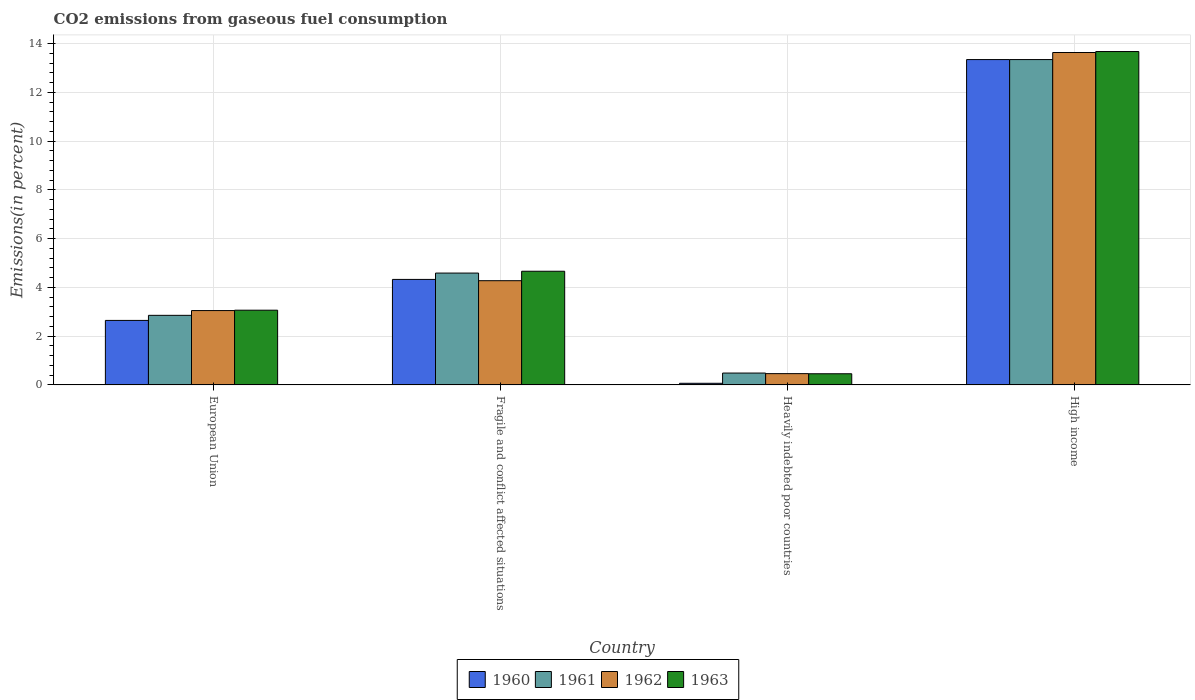How many groups of bars are there?
Provide a succinct answer. 4. How many bars are there on the 4th tick from the left?
Ensure brevity in your answer.  4. How many bars are there on the 1st tick from the right?
Keep it short and to the point. 4. What is the total CO2 emitted in 1962 in High income?
Your response must be concise. 13.63. Across all countries, what is the maximum total CO2 emitted in 1960?
Give a very brief answer. 13.34. Across all countries, what is the minimum total CO2 emitted in 1962?
Offer a very short reply. 0.46. In which country was the total CO2 emitted in 1960 minimum?
Offer a very short reply. Heavily indebted poor countries. What is the total total CO2 emitted in 1960 in the graph?
Provide a succinct answer. 20.38. What is the difference between the total CO2 emitted in 1961 in European Union and that in Heavily indebted poor countries?
Give a very brief answer. 2.37. What is the difference between the total CO2 emitted in 1962 in European Union and the total CO2 emitted in 1960 in Heavily indebted poor countries?
Provide a short and direct response. 2.98. What is the average total CO2 emitted in 1963 per country?
Give a very brief answer. 5.46. What is the difference between the total CO2 emitted of/in 1961 and total CO2 emitted of/in 1962 in Fragile and conflict affected situations?
Provide a short and direct response. 0.31. What is the ratio of the total CO2 emitted in 1963 in Fragile and conflict affected situations to that in Heavily indebted poor countries?
Ensure brevity in your answer.  10.19. Is the total CO2 emitted in 1963 in Fragile and conflict affected situations less than that in High income?
Make the answer very short. Yes. Is the difference between the total CO2 emitted in 1961 in Fragile and conflict affected situations and High income greater than the difference between the total CO2 emitted in 1962 in Fragile and conflict affected situations and High income?
Your response must be concise. Yes. What is the difference between the highest and the second highest total CO2 emitted in 1963?
Make the answer very short. -1.6. What is the difference between the highest and the lowest total CO2 emitted in 1963?
Ensure brevity in your answer.  13.22. Is the sum of the total CO2 emitted in 1963 in European Union and High income greater than the maximum total CO2 emitted in 1960 across all countries?
Provide a succinct answer. Yes. What does the 2nd bar from the left in European Union represents?
Ensure brevity in your answer.  1961. Is it the case that in every country, the sum of the total CO2 emitted in 1962 and total CO2 emitted in 1960 is greater than the total CO2 emitted in 1963?
Your response must be concise. Yes. How many bars are there?
Make the answer very short. 16. Are all the bars in the graph horizontal?
Ensure brevity in your answer.  No. How many countries are there in the graph?
Offer a very short reply. 4. What is the title of the graph?
Ensure brevity in your answer.  CO2 emissions from gaseous fuel consumption. Does "1987" appear as one of the legend labels in the graph?
Your response must be concise. No. What is the label or title of the X-axis?
Your response must be concise. Country. What is the label or title of the Y-axis?
Ensure brevity in your answer.  Emissions(in percent). What is the Emissions(in percent) in 1960 in European Union?
Ensure brevity in your answer.  2.65. What is the Emissions(in percent) of 1961 in European Union?
Give a very brief answer. 2.85. What is the Emissions(in percent) in 1962 in European Union?
Keep it short and to the point. 3.05. What is the Emissions(in percent) in 1963 in European Union?
Your answer should be very brief. 3.06. What is the Emissions(in percent) of 1960 in Fragile and conflict affected situations?
Your response must be concise. 4.33. What is the Emissions(in percent) of 1961 in Fragile and conflict affected situations?
Your answer should be compact. 4.59. What is the Emissions(in percent) in 1962 in Fragile and conflict affected situations?
Offer a very short reply. 4.27. What is the Emissions(in percent) in 1963 in Fragile and conflict affected situations?
Provide a short and direct response. 4.66. What is the Emissions(in percent) of 1960 in Heavily indebted poor countries?
Provide a short and direct response. 0.07. What is the Emissions(in percent) of 1961 in Heavily indebted poor countries?
Offer a terse response. 0.49. What is the Emissions(in percent) of 1962 in Heavily indebted poor countries?
Provide a succinct answer. 0.46. What is the Emissions(in percent) of 1963 in Heavily indebted poor countries?
Your answer should be very brief. 0.46. What is the Emissions(in percent) of 1960 in High income?
Keep it short and to the point. 13.34. What is the Emissions(in percent) in 1961 in High income?
Make the answer very short. 13.35. What is the Emissions(in percent) of 1962 in High income?
Provide a short and direct response. 13.63. What is the Emissions(in percent) in 1963 in High income?
Give a very brief answer. 13.67. Across all countries, what is the maximum Emissions(in percent) of 1960?
Offer a terse response. 13.34. Across all countries, what is the maximum Emissions(in percent) in 1961?
Your answer should be very brief. 13.35. Across all countries, what is the maximum Emissions(in percent) in 1962?
Offer a very short reply. 13.63. Across all countries, what is the maximum Emissions(in percent) of 1963?
Give a very brief answer. 13.67. Across all countries, what is the minimum Emissions(in percent) in 1960?
Offer a terse response. 0.07. Across all countries, what is the minimum Emissions(in percent) in 1961?
Your response must be concise. 0.49. Across all countries, what is the minimum Emissions(in percent) in 1962?
Your answer should be compact. 0.46. Across all countries, what is the minimum Emissions(in percent) in 1963?
Keep it short and to the point. 0.46. What is the total Emissions(in percent) in 1960 in the graph?
Provide a short and direct response. 20.38. What is the total Emissions(in percent) in 1961 in the graph?
Offer a terse response. 21.27. What is the total Emissions(in percent) of 1962 in the graph?
Provide a short and direct response. 21.42. What is the total Emissions(in percent) of 1963 in the graph?
Your response must be concise. 21.86. What is the difference between the Emissions(in percent) of 1960 in European Union and that in Fragile and conflict affected situations?
Make the answer very short. -1.68. What is the difference between the Emissions(in percent) in 1961 in European Union and that in Fragile and conflict affected situations?
Provide a short and direct response. -1.73. What is the difference between the Emissions(in percent) in 1962 in European Union and that in Fragile and conflict affected situations?
Your answer should be very brief. -1.23. What is the difference between the Emissions(in percent) of 1963 in European Union and that in Fragile and conflict affected situations?
Your answer should be very brief. -1.6. What is the difference between the Emissions(in percent) of 1960 in European Union and that in Heavily indebted poor countries?
Make the answer very short. 2.58. What is the difference between the Emissions(in percent) of 1961 in European Union and that in Heavily indebted poor countries?
Provide a short and direct response. 2.37. What is the difference between the Emissions(in percent) of 1962 in European Union and that in Heavily indebted poor countries?
Keep it short and to the point. 2.59. What is the difference between the Emissions(in percent) in 1963 in European Union and that in Heavily indebted poor countries?
Ensure brevity in your answer.  2.61. What is the difference between the Emissions(in percent) in 1960 in European Union and that in High income?
Provide a succinct answer. -10.7. What is the difference between the Emissions(in percent) of 1961 in European Union and that in High income?
Provide a short and direct response. -10.49. What is the difference between the Emissions(in percent) in 1962 in European Union and that in High income?
Offer a terse response. -10.59. What is the difference between the Emissions(in percent) in 1963 in European Union and that in High income?
Offer a terse response. -10.61. What is the difference between the Emissions(in percent) of 1960 in Fragile and conflict affected situations and that in Heavily indebted poor countries?
Ensure brevity in your answer.  4.26. What is the difference between the Emissions(in percent) of 1961 in Fragile and conflict affected situations and that in Heavily indebted poor countries?
Offer a terse response. 4.1. What is the difference between the Emissions(in percent) of 1962 in Fragile and conflict affected situations and that in Heavily indebted poor countries?
Provide a short and direct response. 3.81. What is the difference between the Emissions(in percent) in 1963 in Fragile and conflict affected situations and that in Heavily indebted poor countries?
Your answer should be compact. 4.2. What is the difference between the Emissions(in percent) of 1960 in Fragile and conflict affected situations and that in High income?
Offer a very short reply. -9.02. What is the difference between the Emissions(in percent) of 1961 in Fragile and conflict affected situations and that in High income?
Ensure brevity in your answer.  -8.76. What is the difference between the Emissions(in percent) in 1962 in Fragile and conflict affected situations and that in High income?
Offer a terse response. -9.36. What is the difference between the Emissions(in percent) in 1963 in Fragile and conflict affected situations and that in High income?
Make the answer very short. -9.01. What is the difference between the Emissions(in percent) in 1960 in Heavily indebted poor countries and that in High income?
Provide a short and direct response. -13.28. What is the difference between the Emissions(in percent) in 1961 in Heavily indebted poor countries and that in High income?
Provide a short and direct response. -12.86. What is the difference between the Emissions(in percent) of 1962 in Heavily indebted poor countries and that in High income?
Keep it short and to the point. -13.17. What is the difference between the Emissions(in percent) in 1963 in Heavily indebted poor countries and that in High income?
Your answer should be very brief. -13.22. What is the difference between the Emissions(in percent) in 1960 in European Union and the Emissions(in percent) in 1961 in Fragile and conflict affected situations?
Your answer should be very brief. -1.94. What is the difference between the Emissions(in percent) in 1960 in European Union and the Emissions(in percent) in 1962 in Fragile and conflict affected situations?
Your answer should be very brief. -1.63. What is the difference between the Emissions(in percent) of 1960 in European Union and the Emissions(in percent) of 1963 in Fragile and conflict affected situations?
Provide a short and direct response. -2.02. What is the difference between the Emissions(in percent) of 1961 in European Union and the Emissions(in percent) of 1962 in Fragile and conflict affected situations?
Your answer should be compact. -1.42. What is the difference between the Emissions(in percent) of 1961 in European Union and the Emissions(in percent) of 1963 in Fragile and conflict affected situations?
Give a very brief answer. -1.81. What is the difference between the Emissions(in percent) in 1962 in European Union and the Emissions(in percent) in 1963 in Fragile and conflict affected situations?
Offer a terse response. -1.61. What is the difference between the Emissions(in percent) of 1960 in European Union and the Emissions(in percent) of 1961 in Heavily indebted poor countries?
Your answer should be compact. 2.16. What is the difference between the Emissions(in percent) in 1960 in European Union and the Emissions(in percent) in 1962 in Heavily indebted poor countries?
Offer a very short reply. 2.18. What is the difference between the Emissions(in percent) of 1960 in European Union and the Emissions(in percent) of 1963 in Heavily indebted poor countries?
Provide a short and direct response. 2.19. What is the difference between the Emissions(in percent) of 1961 in European Union and the Emissions(in percent) of 1962 in Heavily indebted poor countries?
Keep it short and to the point. 2.39. What is the difference between the Emissions(in percent) of 1961 in European Union and the Emissions(in percent) of 1963 in Heavily indebted poor countries?
Your answer should be compact. 2.4. What is the difference between the Emissions(in percent) of 1962 in European Union and the Emissions(in percent) of 1963 in Heavily indebted poor countries?
Keep it short and to the point. 2.59. What is the difference between the Emissions(in percent) in 1960 in European Union and the Emissions(in percent) in 1961 in High income?
Your response must be concise. -10.7. What is the difference between the Emissions(in percent) of 1960 in European Union and the Emissions(in percent) of 1962 in High income?
Keep it short and to the point. -10.99. What is the difference between the Emissions(in percent) in 1960 in European Union and the Emissions(in percent) in 1963 in High income?
Make the answer very short. -11.03. What is the difference between the Emissions(in percent) in 1961 in European Union and the Emissions(in percent) in 1962 in High income?
Your answer should be compact. -10.78. What is the difference between the Emissions(in percent) of 1961 in European Union and the Emissions(in percent) of 1963 in High income?
Provide a short and direct response. -10.82. What is the difference between the Emissions(in percent) of 1962 in European Union and the Emissions(in percent) of 1963 in High income?
Give a very brief answer. -10.62. What is the difference between the Emissions(in percent) in 1960 in Fragile and conflict affected situations and the Emissions(in percent) in 1961 in Heavily indebted poor countries?
Offer a terse response. 3.84. What is the difference between the Emissions(in percent) of 1960 in Fragile and conflict affected situations and the Emissions(in percent) of 1962 in Heavily indebted poor countries?
Ensure brevity in your answer.  3.86. What is the difference between the Emissions(in percent) in 1960 in Fragile and conflict affected situations and the Emissions(in percent) in 1963 in Heavily indebted poor countries?
Your response must be concise. 3.87. What is the difference between the Emissions(in percent) in 1961 in Fragile and conflict affected situations and the Emissions(in percent) in 1962 in Heavily indebted poor countries?
Offer a terse response. 4.12. What is the difference between the Emissions(in percent) of 1961 in Fragile and conflict affected situations and the Emissions(in percent) of 1963 in Heavily indebted poor countries?
Offer a very short reply. 4.13. What is the difference between the Emissions(in percent) of 1962 in Fragile and conflict affected situations and the Emissions(in percent) of 1963 in Heavily indebted poor countries?
Offer a terse response. 3.82. What is the difference between the Emissions(in percent) of 1960 in Fragile and conflict affected situations and the Emissions(in percent) of 1961 in High income?
Your answer should be compact. -9.02. What is the difference between the Emissions(in percent) in 1960 in Fragile and conflict affected situations and the Emissions(in percent) in 1962 in High income?
Provide a short and direct response. -9.31. What is the difference between the Emissions(in percent) in 1960 in Fragile and conflict affected situations and the Emissions(in percent) in 1963 in High income?
Make the answer very short. -9.35. What is the difference between the Emissions(in percent) in 1961 in Fragile and conflict affected situations and the Emissions(in percent) in 1962 in High income?
Your answer should be very brief. -9.05. What is the difference between the Emissions(in percent) of 1961 in Fragile and conflict affected situations and the Emissions(in percent) of 1963 in High income?
Keep it short and to the point. -9.09. What is the difference between the Emissions(in percent) of 1962 in Fragile and conflict affected situations and the Emissions(in percent) of 1963 in High income?
Provide a succinct answer. -9.4. What is the difference between the Emissions(in percent) of 1960 in Heavily indebted poor countries and the Emissions(in percent) of 1961 in High income?
Ensure brevity in your answer.  -13.28. What is the difference between the Emissions(in percent) in 1960 in Heavily indebted poor countries and the Emissions(in percent) in 1962 in High income?
Provide a short and direct response. -13.57. What is the difference between the Emissions(in percent) of 1960 in Heavily indebted poor countries and the Emissions(in percent) of 1963 in High income?
Offer a very short reply. -13.61. What is the difference between the Emissions(in percent) of 1961 in Heavily indebted poor countries and the Emissions(in percent) of 1962 in High income?
Your answer should be compact. -13.15. What is the difference between the Emissions(in percent) in 1961 in Heavily indebted poor countries and the Emissions(in percent) in 1963 in High income?
Give a very brief answer. -13.19. What is the difference between the Emissions(in percent) of 1962 in Heavily indebted poor countries and the Emissions(in percent) of 1963 in High income?
Provide a short and direct response. -13.21. What is the average Emissions(in percent) of 1960 per country?
Make the answer very short. 5.1. What is the average Emissions(in percent) in 1961 per country?
Ensure brevity in your answer.  5.32. What is the average Emissions(in percent) of 1962 per country?
Make the answer very short. 5.36. What is the average Emissions(in percent) in 1963 per country?
Offer a very short reply. 5.46. What is the difference between the Emissions(in percent) in 1960 and Emissions(in percent) in 1961 in European Union?
Your answer should be very brief. -0.21. What is the difference between the Emissions(in percent) in 1960 and Emissions(in percent) in 1962 in European Union?
Give a very brief answer. -0.4. What is the difference between the Emissions(in percent) in 1960 and Emissions(in percent) in 1963 in European Union?
Your answer should be very brief. -0.42. What is the difference between the Emissions(in percent) in 1961 and Emissions(in percent) in 1962 in European Union?
Make the answer very short. -0.2. What is the difference between the Emissions(in percent) in 1961 and Emissions(in percent) in 1963 in European Union?
Your response must be concise. -0.21. What is the difference between the Emissions(in percent) of 1962 and Emissions(in percent) of 1963 in European Union?
Keep it short and to the point. -0.01. What is the difference between the Emissions(in percent) of 1960 and Emissions(in percent) of 1961 in Fragile and conflict affected situations?
Keep it short and to the point. -0.26. What is the difference between the Emissions(in percent) of 1960 and Emissions(in percent) of 1962 in Fragile and conflict affected situations?
Make the answer very short. 0.05. What is the difference between the Emissions(in percent) of 1960 and Emissions(in percent) of 1963 in Fragile and conflict affected situations?
Provide a succinct answer. -0.34. What is the difference between the Emissions(in percent) of 1961 and Emissions(in percent) of 1962 in Fragile and conflict affected situations?
Ensure brevity in your answer.  0.31. What is the difference between the Emissions(in percent) of 1961 and Emissions(in percent) of 1963 in Fragile and conflict affected situations?
Offer a terse response. -0.07. What is the difference between the Emissions(in percent) in 1962 and Emissions(in percent) in 1963 in Fragile and conflict affected situations?
Ensure brevity in your answer.  -0.39. What is the difference between the Emissions(in percent) in 1960 and Emissions(in percent) in 1961 in Heavily indebted poor countries?
Offer a very short reply. -0.42. What is the difference between the Emissions(in percent) of 1960 and Emissions(in percent) of 1962 in Heavily indebted poor countries?
Offer a terse response. -0.4. What is the difference between the Emissions(in percent) of 1960 and Emissions(in percent) of 1963 in Heavily indebted poor countries?
Offer a very short reply. -0.39. What is the difference between the Emissions(in percent) in 1961 and Emissions(in percent) in 1962 in Heavily indebted poor countries?
Make the answer very short. 0.02. What is the difference between the Emissions(in percent) in 1961 and Emissions(in percent) in 1963 in Heavily indebted poor countries?
Make the answer very short. 0.03. What is the difference between the Emissions(in percent) of 1962 and Emissions(in percent) of 1963 in Heavily indebted poor countries?
Your answer should be compact. 0.01. What is the difference between the Emissions(in percent) of 1960 and Emissions(in percent) of 1961 in High income?
Keep it short and to the point. -0. What is the difference between the Emissions(in percent) of 1960 and Emissions(in percent) of 1962 in High income?
Make the answer very short. -0.29. What is the difference between the Emissions(in percent) in 1960 and Emissions(in percent) in 1963 in High income?
Provide a short and direct response. -0.33. What is the difference between the Emissions(in percent) of 1961 and Emissions(in percent) of 1962 in High income?
Offer a terse response. -0.29. What is the difference between the Emissions(in percent) of 1961 and Emissions(in percent) of 1963 in High income?
Ensure brevity in your answer.  -0.33. What is the difference between the Emissions(in percent) of 1962 and Emissions(in percent) of 1963 in High income?
Ensure brevity in your answer.  -0.04. What is the ratio of the Emissions(in percent) in 1960 in European Union to that in Fragile and conflict affected situations?
Your answer should be compact. 0.61. What is the ratio of the Emissions(in percent) in 1961 in European Union to that in Fragile and conflict affected situations?
Ensure brevity in your answer.  0.62. What is the ratio of the Emissions(in percent) of 1962 in European Union to that in Fragile and conflict affected situations?
Keep it short and to the point. 0.71. What is the ratio of the Emissions(in percent) in 1963 in European Union to that in Fragile and conflict affected situations?
Provide a succinct answer. 0.66. What is the ratio of the Emissions(in percent) in 1960 in European Union to that in Heavily indebted poor countries?
Offer a very short reply. 39.61. What is the ratio of the Emissions(in percent) of 1961 in European Union to that in Heavily indebted poor countries?
Give a very brief answer. 5.87. What is the ratio of the Emissions(in percent) of 1962 in European Union to that in Heavily indebted poor countries?
Provide a short and direct response. 6.59. What is the ratio of the Emissions(in percent) in 1963 in European Union to that in Heavily indebted poor countries?
Give a very brief answer. 6.7. What is the ratio of the Emissions(in percent) in 1960 in European Union to that in High income?
Provide a succinct answer. 0.2. What is the ratio of the Emissions(in percent) of 1961 in European Union to that in High income?
Give a very brief answer. 0.21. What is the ratio of the Emissions(in percent) in 1962 in European Union to that in High income?
Keep it short and to the point. 0.22. What is the ratio of the Emissions(in percent) of 1963 in European Union to that in High income?
Make the answer very short. 0.22. What is the ratio of the Emissions(in percent) of 1960 in Fragile and conflict affected situations to that in Heavily indebted poor countries?
Your response must be concise. 64.79. What is the ratio of the Emissions(in percent) in 1961 in Fragile and conflict affected situations to that in Heavily indebted poor countries?
Make the answer very short. 9.44. What is the ratio of the Emissions(in percent) of 1962 in Fragile and conflict affected situations to that in Heavily indebted poor countries?
Provide a short and direct response. 9.23. What is the ratio of the Emissions(in percent) of 1963 in Fragile and conflict affected situations to that in Heavily indebted poor countries?
Offer a terse response. 10.19. What is the ratio of the Emissions(in percent) in 1960 in Fragile and conflict affected situations to that in High income?
Your response must be concise. 0.32. What is the ratio of the Emissions(in percent) of 1961 in Fragile and conflict affected situations to that in High income?
Give a very brief answer. 0.34. What is the ratio of the Emissions(in percent) in 1962 in Fragile and conflict affected situations to that in High income?
Keep it short and to the point. 0.31. What is the ratio of the Emissions(in percent) of 1963 in Fragile and conflict affected situations to that in High income?
Your answer should be compact. 0.34. What is the ratio of the Emissions(in percent) of 1960 in Heavily indebted poor countries to that in High income?
Keep it short and to the point. 0.01. What is the ratio of the Emissions(in percent) of 1961 in Heavily indebted poor countries to that in High income?
Your answer should be very brief. 0.04. What is the ratio of the Emissions(in percent) of 1962 in Heavily indebted poor countries to that in High income?
Your response must be concise. 0.03. What is the ratio of the Emissions(in percent) in 1963 in Heavily indebted poor countries to that in High income?
Keep it short and to the point. 0.03. What is the difference between the highest and the second highest Emissions(in percent) of 1960?
Your answer should be very brief. 9.02. What is the difference between the highest and the second highest Emissions(in percent) in 1961?
Provide a short and direct response. 8.76. What is the difference between the highest and the second highest Emissions(in percent) in 1962?
Your answer should be very brief. 9.36. What is the difference between the highest and the second highest Emissions(in percent) in 1963?
Make the answer very short. 9.01. What is the difference between the highest and the lowest Emissions(in percent) in 1960?
Offer a very short reply. 13.28. What is the difference between the highest and the lowest Emissions(in percent) of 1961?
Provide a short and direct response. 12.86. What is the difference between the highest and the lowest Emissions(in percent) in 1962?
Your answer should be very brief. 13.17. What is the difference between the highest and the lowest Emissions(in percent) of 1963?
Provide a short and direct response. 13.22. 